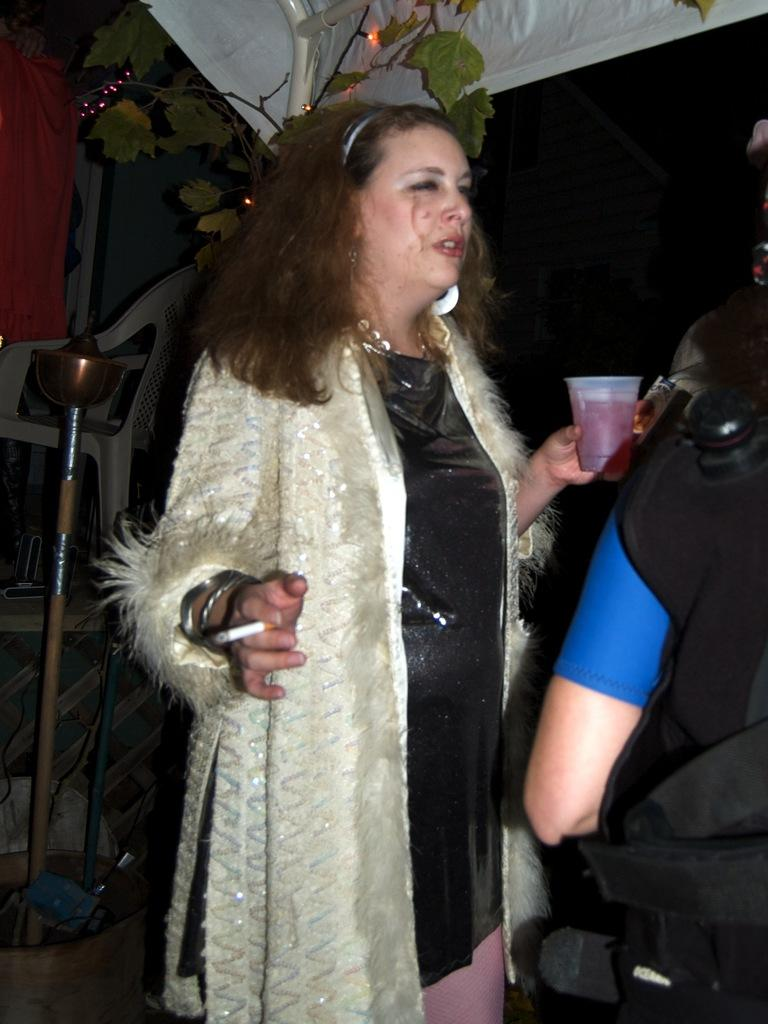Who is the main subject in the image? There is a lady in the image. What is the lady holding in her hand? The lady is holding a glass and a cigar. What can be seen at the top of the image? There are lights visible at the top of the image. Is the lady taking a bath in the image? There is no indication in the image that the lady is taking a bath. What type of war is depicted in the image? There is no war depicted in the image; it features a lady holding a glass and a cigar. 